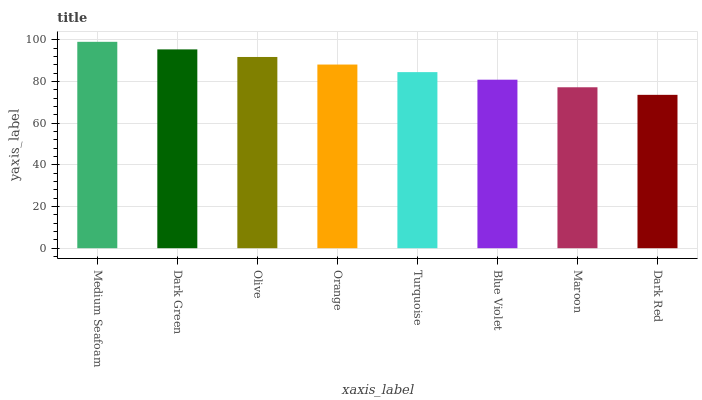Is Dark Red the minimum?
Answer yes or no. Yes. Is Medium Seafoam the maximum?
Answer yes or no. Yes. Is Dark Green the minimum?
Answer yes or no. No. Is Dark Green the maximum?
Answer yes or no. No. Is Medium Seafoam greater than Dark Green?
Answer yes or no. Yes. Is Dark Green less than Medium Seafoam?
Answer yes or no. Yes. Is Dark Green greater than Medium Seafoam?
Answer yes or no. No. Is Medium Seafoam less than Dark Green?
Answer yes or no. No. Is Orange the high median?
Answer yes or no. Yes. Is Turquoise the low median?
Answer yes or no. Yes. Is Blue Violet the high median?
Answer yes or no. No. Is Maroon the low median?
Answer yes or no. No. 